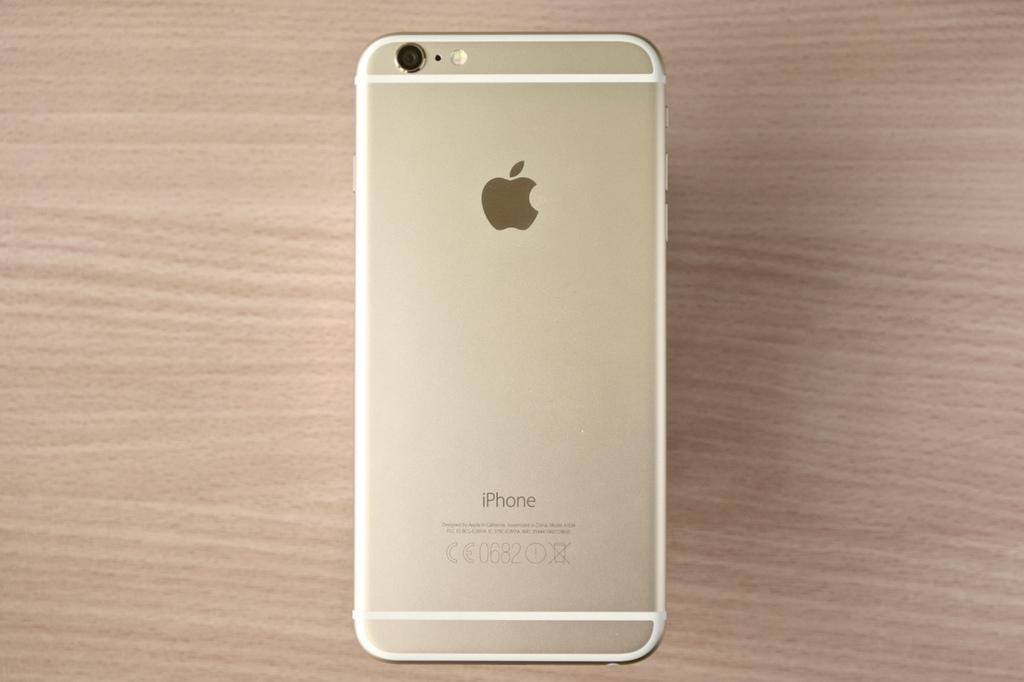<image>
Present a compact description of the photo's key features. An Apple Iphone with a beige back lies on a brown table. 